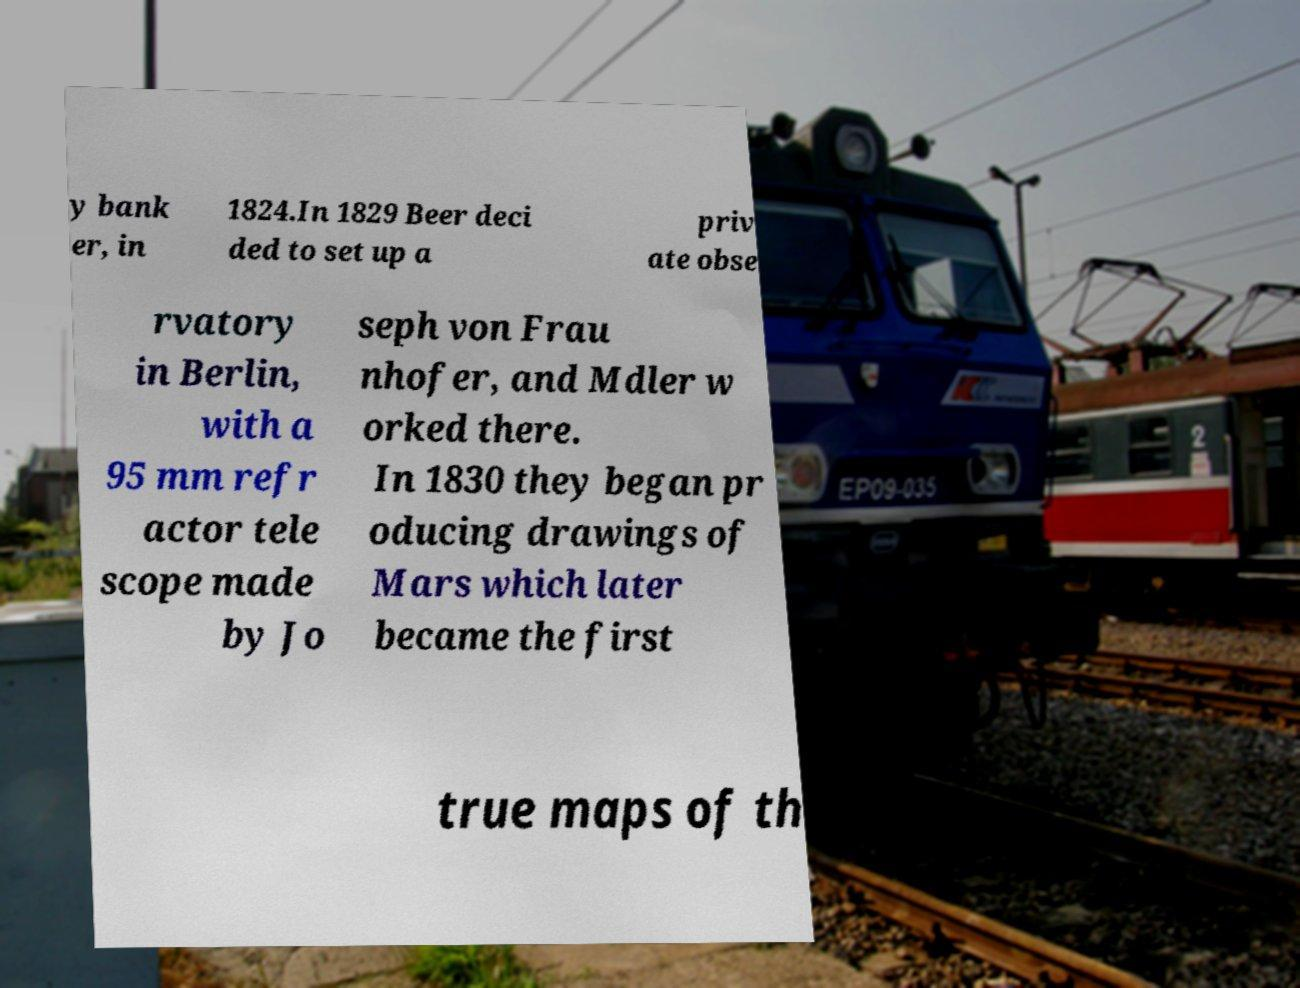Can you read and provide the text displayed in the image?This photo seems to have some interesting text. Can you extract and type it out for me? y bank er, in 1824.In 1829 Beer deci ded to set up a priv ate obse rvatory in Berlin, with a 95 mm refr actor tele scope made by Jo seph von Frau nhofer, and Mdler w orked there. In 1830 they began pr oducing drawings of Mars which later became the first true maps of th 